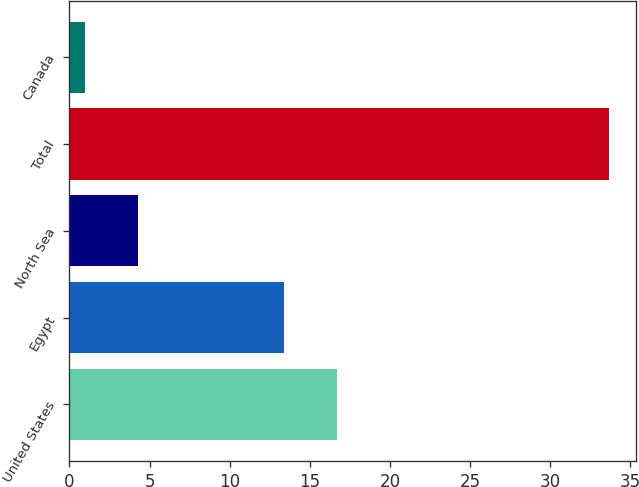<chart> <loc_0><loc_0><loc_500><loc_500><bar_chart><fcel>United States<fcel>Egypt<fcel>North Sea<fcel>Total<fcel>Canada<nl><fcel>16.67<fcel>13.4<fcel>4.27<fcel>33.7<fcel>1<nl></chart> 